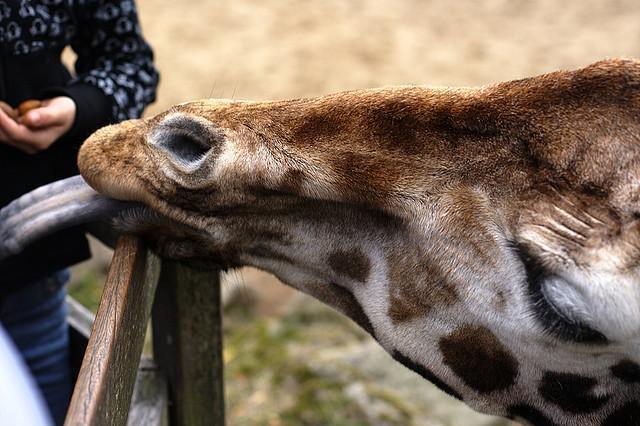How many chairs have blue blankets on them?
Give a very brief answer. 0. 